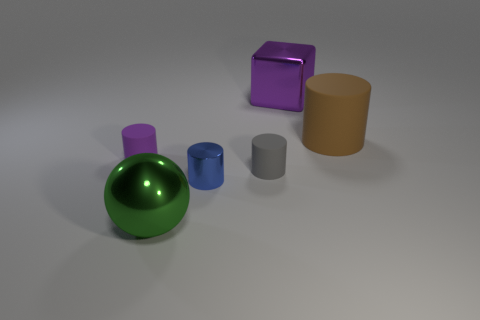How would you describe the lighting in this scene? The lighting in the scene is soft and diffused, creating gentle shadows and a calm atmosphere. It looks as though it's simulated studio lighting with an overhead source. 